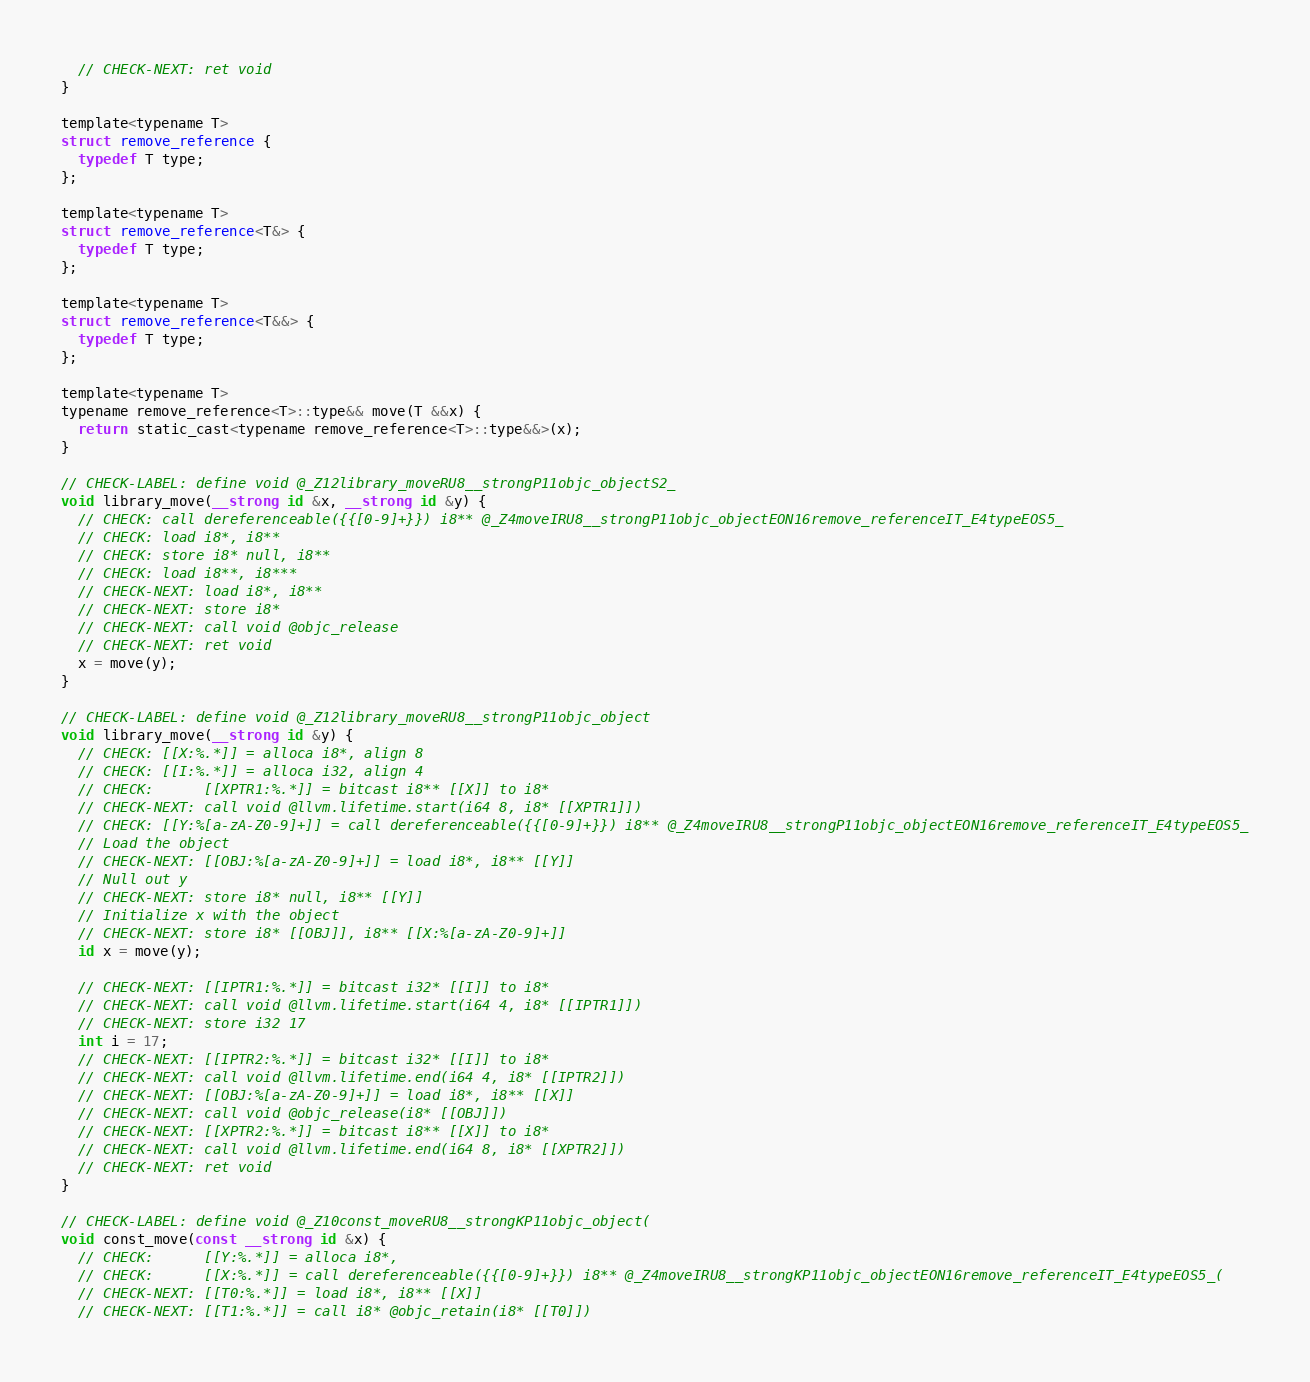<code> <loc_0><loc_0><loc_500><loc_500><_ObjectiveC_>  // CHECK-NEXT: ret void
}

template<typename T>
struct remove_reference {
  typedef T type;
};

template<typename T>
struct remove_reference<T&> {
  typedef T type;
};

template<typename T>
struct remove_reference<T&&> {
  typedef T type;
};

template<typename T> 
typename remove_reference<T>::type&& move(T &&x) { 
  return static_cast<typename remove_reference<T>::type&&>(x); 
}

// CHECK-LABEL: define void @_Z12library_moveRU8__strongP11objc_objectS2_
void library_move(__strong id &x, __strong id &y) {
  // CHECK: call dereferenceable({{[0-9]+}}) i8** @_Z4moveIRU8__strongP11objc_objectEON16remove_referenceIT_E4typeEOS5_
  // CHECK: load i8*, i8**
  // CHECK: store i8* null, i8**
  // CHECK: load i8**, i8***
  // CHECK-NEXT: load i8*, i8**
  // CHECK-NEXT: store i8*
  // CHECK-NEXT: call void @objc_release
  // CHECK-NEXT: ret void
  x = move(y);
}

// CHECK-LABEL: define void @_Z12library_moveRU8__strongP11objc_object
void library_move(__strong id &y) {
  // CHECK: [[X:%.*]] = alloca i8*, align 8
  // CHECK: [[I:%.*]] = alloca i32, align 4
  // CHECK:      [[XPTR1:%.*]] = bitcast i8** [[X]] to i8*
  // CHECK-NEXT: call void @llvm.lifetime.start(i64 8, i8* [[XPTR1]])
  // CHECK: [[Y:%[a-zA-Z0-9]+]] = call dereferenceable({{[0-9]+}}) i8** @_Z4moveIRU8__strongP11objc_objectEON16remove_referenceIT_E4typeEOS5_
  // Load the object
  // CHECK-NEXT: [[OBJ:%[a-zA-Z0-9]+]] = load i8*, i8** [[Y]]
  // Null out y
  // CHECK-NEXT: store i8* null, i8** [[Y]]
  // Initialize x with the object
  // CHECK-NEXT: store i8* [[OBJ]], i8** [[X:%[a-zA-Z0-9]+]]
  id x = move(y);

  // CHECK-NEXT: [[IPTR1:%.*]] = bitcast i32* [[I]] to i8*
  // CHECK-NEXT: call void @llvm.lifetime.start(i64 4, i8* [[IPTR1]])
  // CHECK-NEXT: store i32 17
  int i = 17;
  // CHECK-NEXT: [[IPTR2:%.*]] = bitcast i32* [[I]] to i8*
  // CHECK-NEXT: call void @llvm.lifetime.end(i64 4, i8* [[IPTR2]])
  // CHECK-NEXT: [[OBJ:%[a-zA-Z0-9]+]] = load i8*, i8** [[X]]
  // CHECK-NEXT: call void @objc_release(i8* [[OBJ]])
  // CHECK-NEXT: [[XPTR2:%.*]] = bitcast i8** [[X]] to i8*
  // CHECK-NEXT: call void @llvm.lifetime.end(i64 8, i8* [[XPTR2]])
  // CHECK-NEXT: ret void
}

// CHECK-LABEL: define void @_Z10const_moveRU8__strongKP11objc_object(
void const_move(const __strong id &x) {
  // CHECK:      [[Y:%.*]] = alloca i8*,
  // CHECK:      [[X:%.*]] = call dereferenceable({{[0-9]+}}) i8** @_Z4moveIRU8__strongKP11objc_objectEON16remove_referenceIT_E4typeEOS5_(
  // CHECK-NEXT: [[T0:%.*]] = load i8*, i8** [[X]]
  // CHECK-NEXT: [[T1:%.*]] = call i8* @objc_retain(i8* [[T0]])</code> 